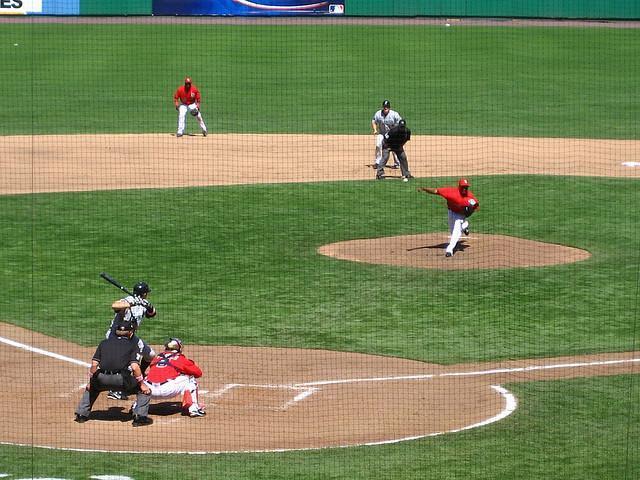How many people are there?
Give a very brief answer. 2. How many chairs don't have a dog on them?
Give a very brief answer. 0. 